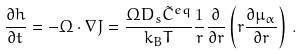<formula> <loc_0><loc_0><loc_500><loc_500>\frac { \partial h } { \partial t } = - \Omega \cdot \nabla J = \frac { \Omega D _ { s } \tilde { C } ^ { e q } } { k _ { B } T } \frac { 1 } { r } \frac { \partial } { \partial r } \left ( r \frac { \partial \mu _ { \alpha } } { \partial r } \right ) \, .</formula> 